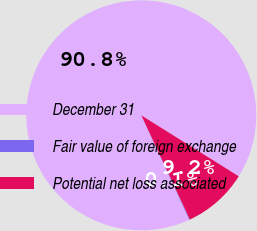<chart> <loc_0><loc_0><loc_500><loc_500><pie_chart><fcel>December 31<fcel>Fair value of foreign exchange<fcel>Potential net loss associated<nl><fcel>90.75%<fcel>0.09%<fcel>9.16%<nl></chart> 